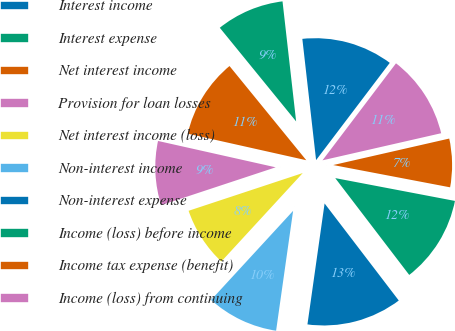Convert chart to OTSL. <chart><loc_0><loc_0><loc_500><loc_500><pie_chart><fcel>Interest income<fcel>Interest expense<fcel>Net interest income<fcel>Provision for loan losses<fcel>Net interest income (loss)<fcel>Non-interest income<fcel>Non-interest expense<fcel>Income (loss) before income<fcel>Income tax expense (benefit)<fcel>Income (loss) from continuing<nl><fcel>12.12%<fcel>9.09%<fcel>10.61%<fcel>8.59%<fcel>8.08%<fcel>9.6%<fcel>12.63%<fcel>11.62%<fcel>6.57%<fcel>11.11%<nl></chart> 